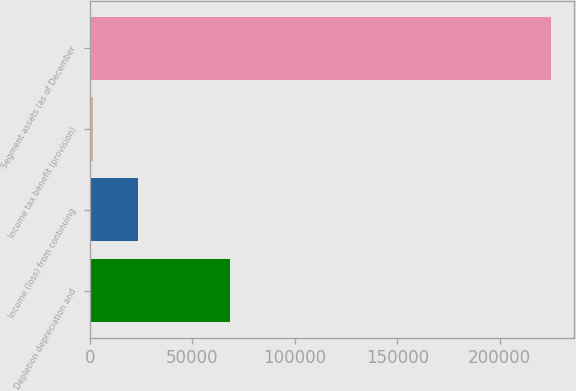<chart> <loc_0><loc_0><loc_500><loc_500><bar_chart><fcel>Depletion depreciation and<fcel>Income (loss) from continuing<fcel>Income tax benefit (provision)<fcel>Segment assets (as of December<nl><fcel>68430.4<fcel>23718.8<fcel>1363<fcel>224921<nl></chart> 